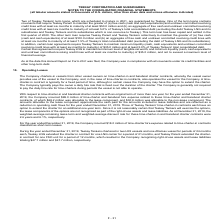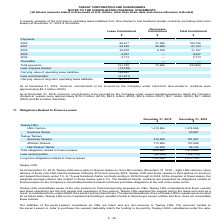From Teekay Corporation's financial document, What was the Lease and Non-Lease commitment in 2020 respectively? The document shows two values: 69,617 and 37,089 (in thousands). From the document: "2020 69,617 37,089 106,706 2020 69,617 37,089 106,706..." Also, What was the Lease and Non-Lease commitment in 2021 respectively? The document shows two values: 54,195 and 26,948 (in thousands). From the document: "2021 54,195 26,948 81,143 2021 54,195 26,948 81,143..." Also, What was the Lease commitment in 2022? According to the financial document, 22,978 (in thousands). The relevant text states: "2022 22,978 8,189 31,167..." Additionally, In which year was the Lease commitment less than 10,000 thousands? The document shows two values: 2023 and 2024. Locate and analyze the lease commitments in column2 . From the document: "2024 5,713 — 5,713 2023 9,227 — 9,227..." Also, can you calculate: What is the change in the Lease commitment from 2020 to 2021? Based on the calculation: 54,195 - 69,617, the result is -15422 (in thousands). This is based on the information: "2020 69,617 37,089 106,706 2021 54,195 26,948 81,143..." The key data points involved are: 54,195, 69,617. Also, can you calculate: What is the average Lease Commitment from 2020 to 2022? To answer this question, I need to perform calculations using the financial data. The calculation is: (69,617 + 54,195 + 22,978) / 3, which equals 48930 (in thousands). This is based on the information: "2020 69,617 37,089 106,706 2021 54,195 26,948 81,143 2022 22,978 8,189 31,167..." The key data points involved are: 22,978, 54,195, 69,617. 